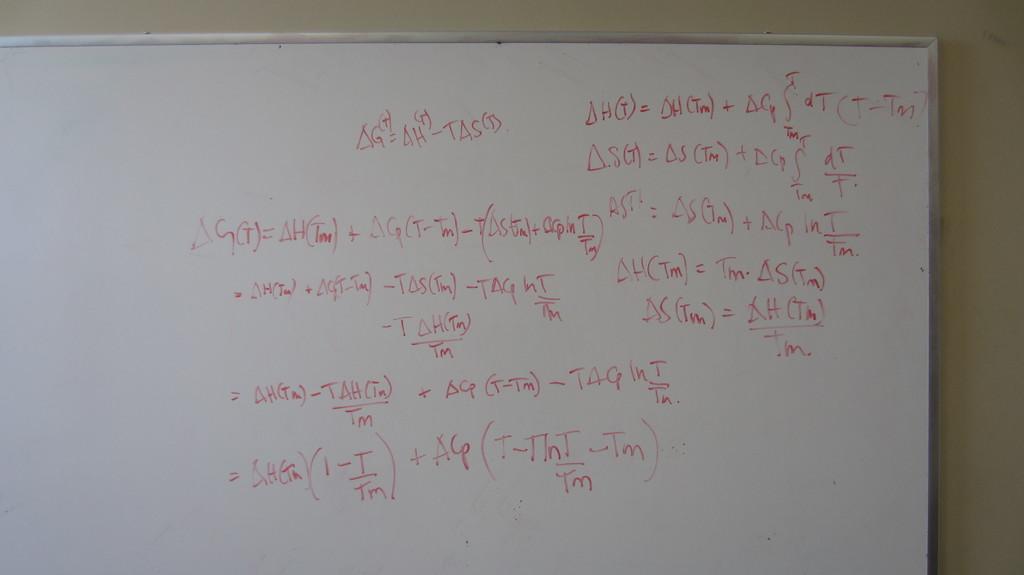Is this an equation?
Your response must be concise. Yes. What are the last characters in the top equation?
Provide a short and direct response. Tas. 